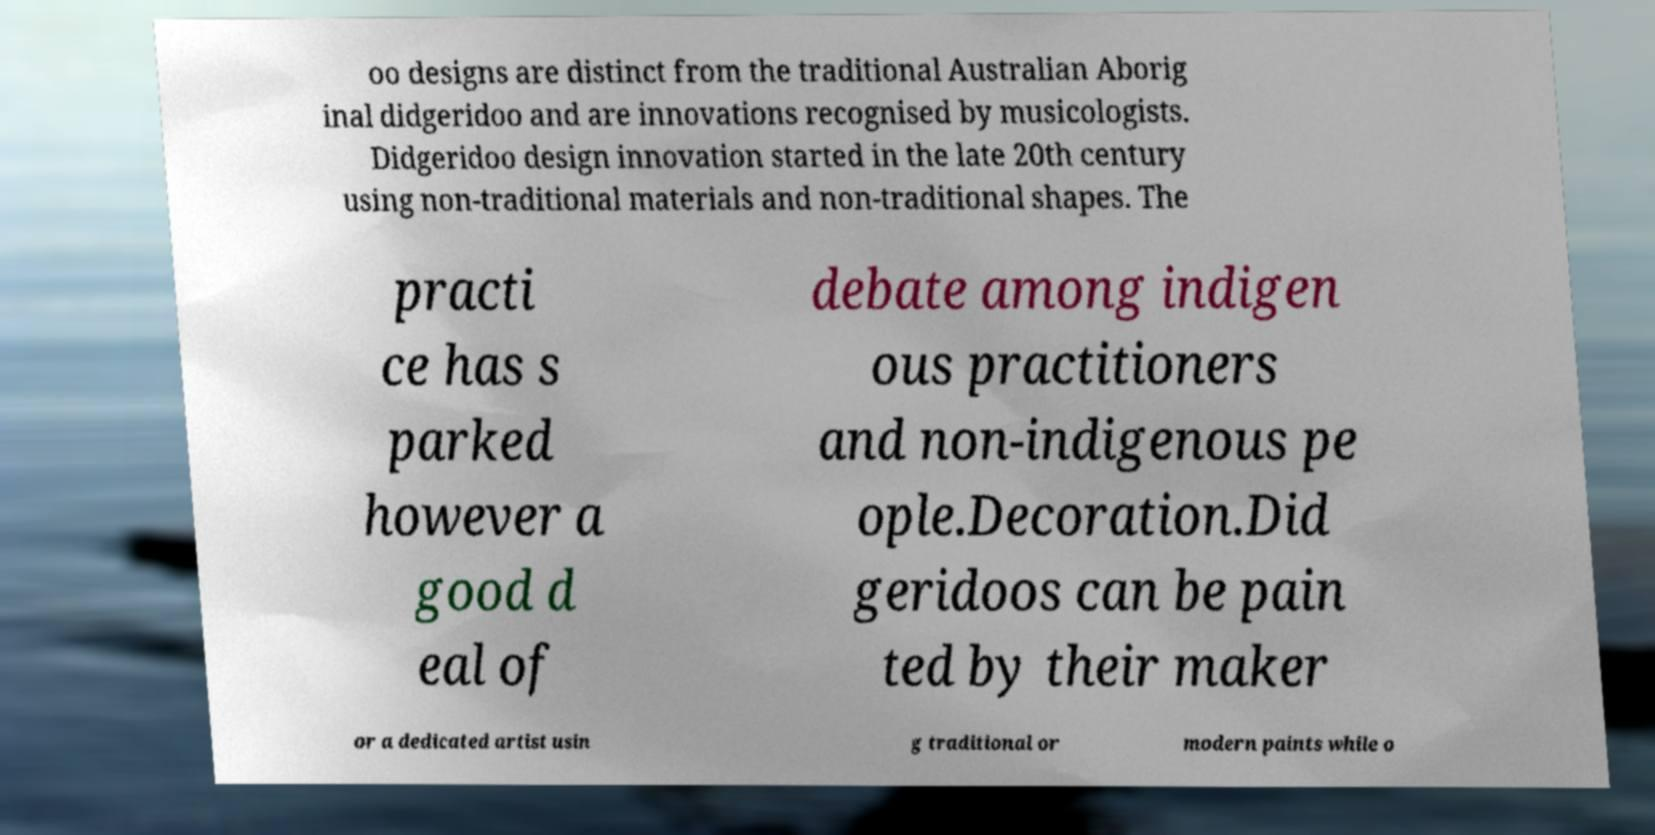Could you extract and type out the text from this image? oo designs are distinct from the traditional Australian Aborig inal didgeridoo and are innovations recognised by musicologists. Didgeridoo design innovation started in the late 20th century using non-traditional materials and non-traditional shapes. The practi ce has s parked however a good d eal of debate among indigen ous practitioners and non-indigenous pe ople.Decoration.Did geridoos can be pain ted by their maker or a dedicated artist usin g traditional or modern paints while o 